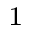<formula> <loc_0><loc_0><loc_500><loc_500>^ { 1 }</formula> 